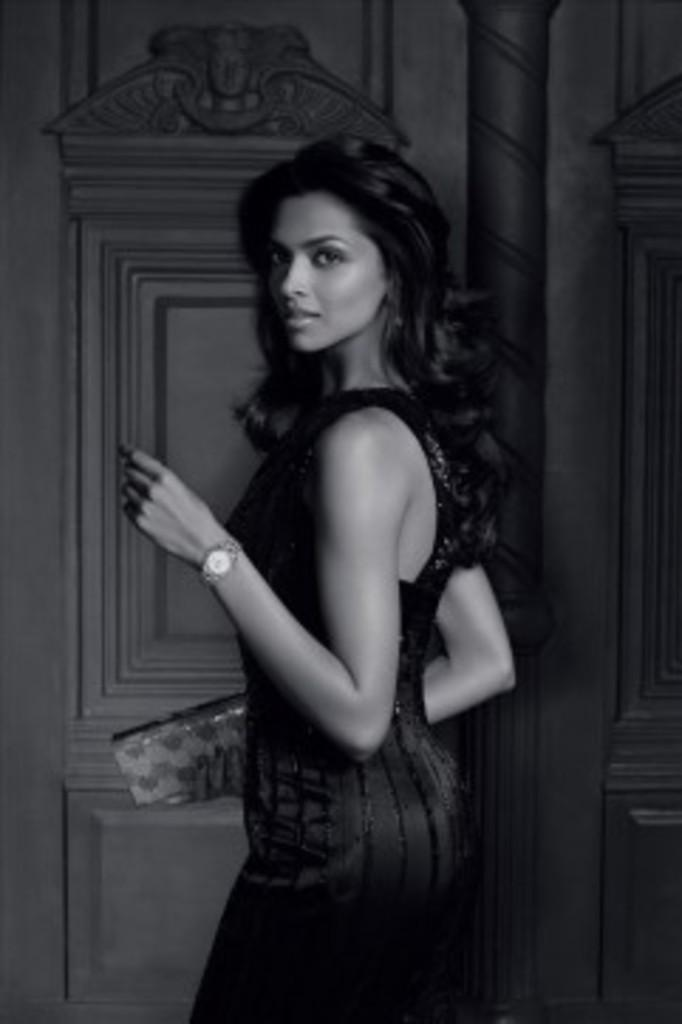What is the color scheme of the image? The image is in black and white. Who is present in the image? There is a woman in the image. What is the woman wearing? The woman is wearing a dress. What is the woman holding in her hand? The woman is holding a wallet in her hand. What can be seen in the background of the image? There is a pillar and a wall in the background of the image. What type of act is the woman performing in the image? There is no act being performed by the woman in the image; she is simply standing and holding a wallet. What knowledge does the woman possess about bears in the image? There is no mention of bears or any related knowledge in the image. 